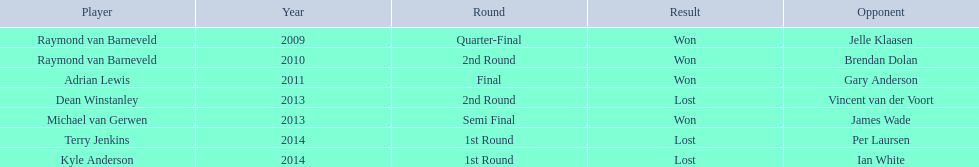Who were the total players involved? Raymond van Barneveld, Raymond van Barneveld, Adrian Lewis, Dean Winstanley, Michael van Gerwen, Terry Jenkins, Kyle Anderson. Which of them played in the year 2014? Terry Jenkins, Kyle Anderson. Who were the opposing players? Per Laursen, Ian White. Which of these individuals triumphed over terry jenkins? Per Laursen. 